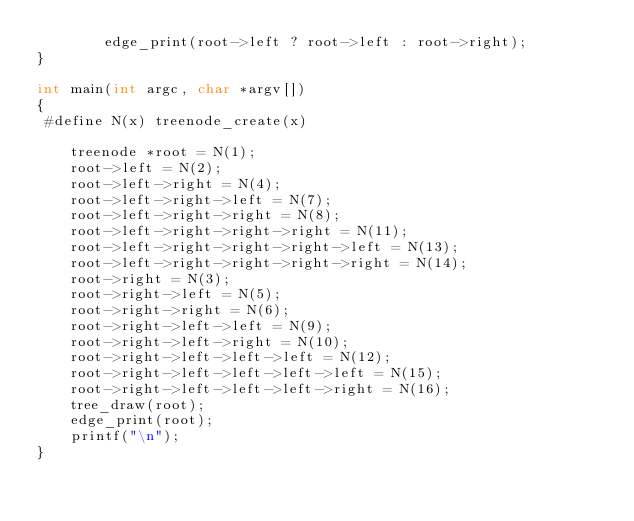Convert code to text. <code><loc_0><loc_0><loc_500><loc_500><_C_>        edge_print(root->left ? root->left : root->right);
}

int main(int argc, char *argv[])
{
 #define N(x) treenode_create(x)

    treenode *root = N(1);
    root->left = N(2);
    root->left->right = N(4);
    root->left->right->left = N(7);
    root->left->right->right = N(8);
    root->left->right->right->right = N(11);
    root->left->right->right->right->left = N(13);
    root->left->right->right->right->right = N(14);
    root->right = N(3);
    root->right->left = N(5);
    root->right->right = N(6);
    root->right->left->left = N(9);
    root->right->left->right = N(10);
    root->right->left->left->left = N(12);
    root->right->left->left->left->left = N(15);
    root->right->left->left->left->right = N(16);
    tree_draw(root);
    edge_print(root);
    printf("\n");
}

</code> 